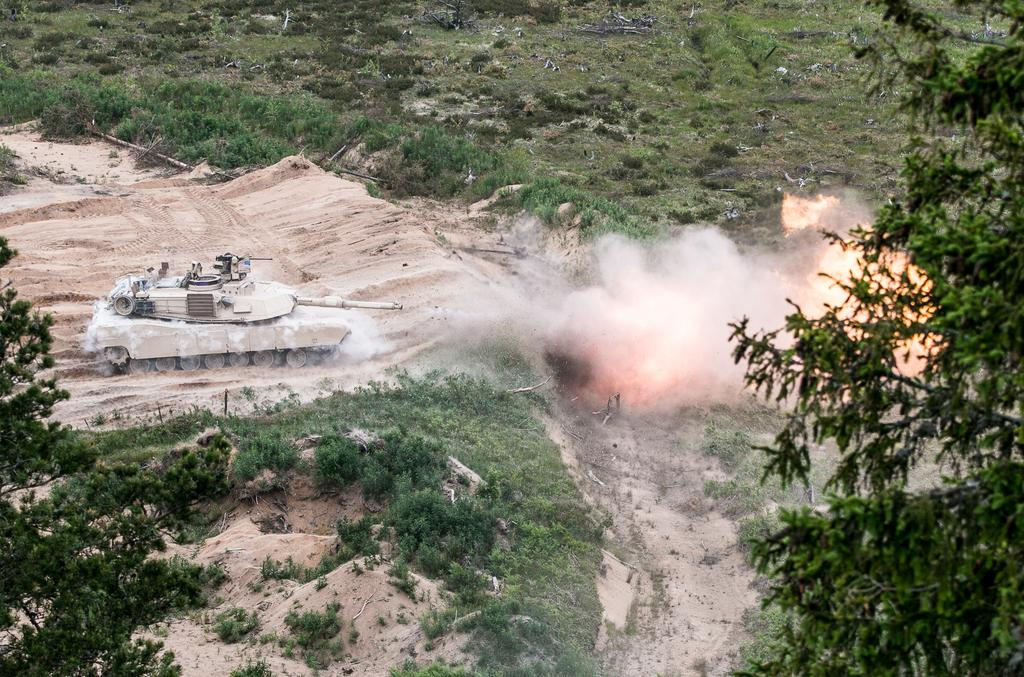What type of vegetation can be seen in the image? There are trees in the image. What is located on the left side of the image? There is a military tanker on the left side of the image. What type of terrain is visible in the image? There is sand in the image. What can be seen in the background of the image? There are plants visible in the background of the image. What is happening on the right side of the image? There is fire on the right side of the image. What type of toys can be seen on the canvas in the image? There is no canvas or toys present in the image. What thought is being expressed by the fire in the image? The fire in the image is not expressing any thought, as it is an inanimate object. 